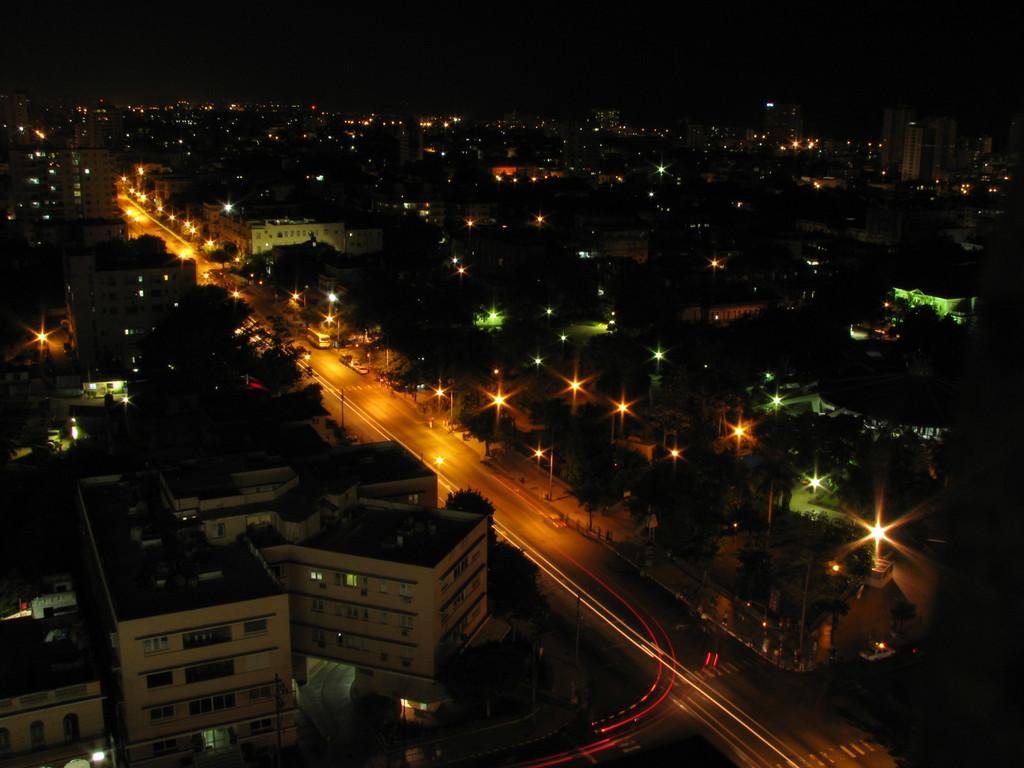How would you summarize this image in a sentence or two? In this image we can see a group of buildings with windows, trees, light poles, a pathway. In the background, we can see the sky. 